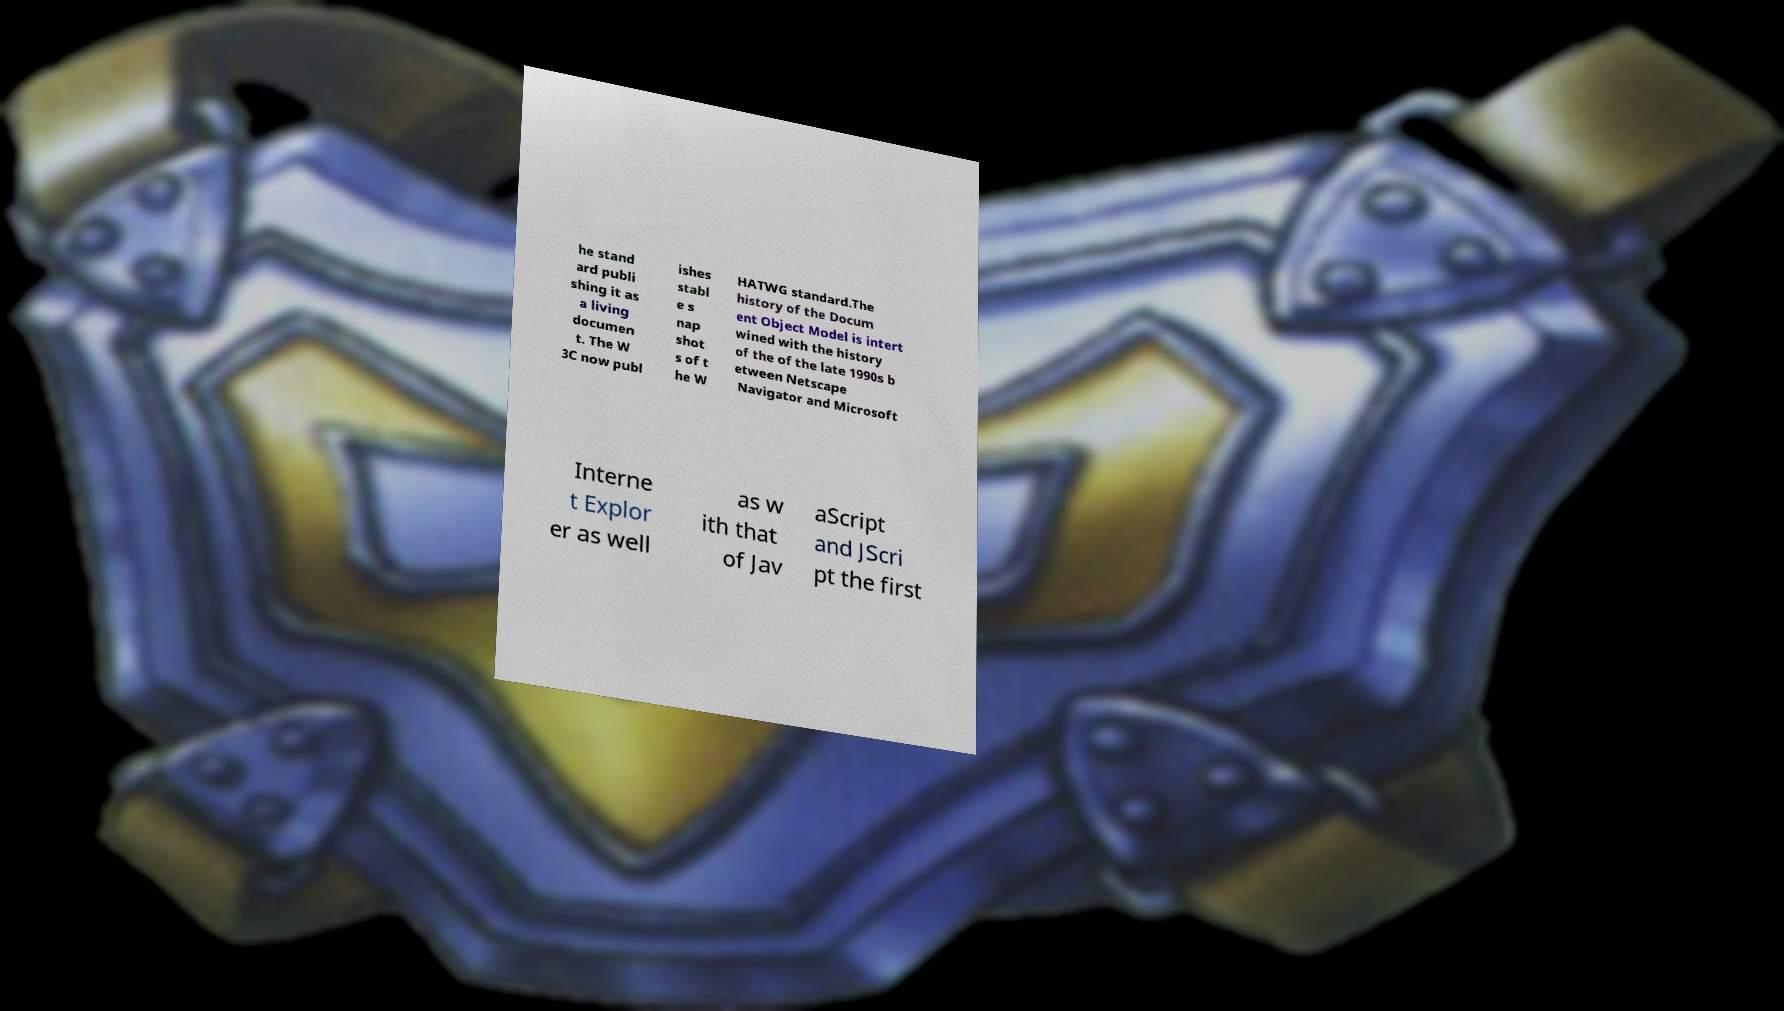Could you extract and type out the text from this image? he stand ard publi shing it as a living documen t. The W 3C now publ ishes stabl e s nap shot s of t he W HATWG standard.The history of the Docum ent Object Model is intert wined with the history of the of the late 1990s b etween Netscape Navigator and Microsoft Interne t Explor er as well as w ith that of Jav aScript and JScri pt the first 